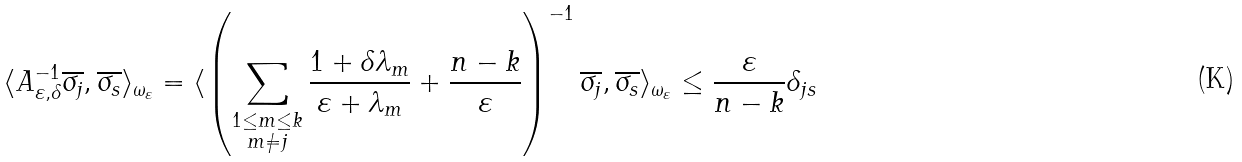Convert formula to latex. <formula><loc_0><loc_0><loc_500><loc_500>\langle A ^ { - 1 } _ { \varepsilon , \delta } \overline { \sigma _ { j } } , \overline { \sigma _ { s } } \rangle _ { \omega _ { \varepsilon } } = \langle \left ( \sum _ { \substack { 1 \leq m \leq k \\ m \neq j } } \frac { 1 + \delta \lambda _ { m } } { \varepsilon + \lambda _ { m } } + \frac { n - k } { \varepsilon } \right ) ^ { - 1 } \overline { \sigma _ { j } } , \overline { \sigma _ { s } } \rangle _ { \omega _ { \varepsilon } } \leq \frac { \varepsilon } { n - k } \delta _ { j s }</formula> 